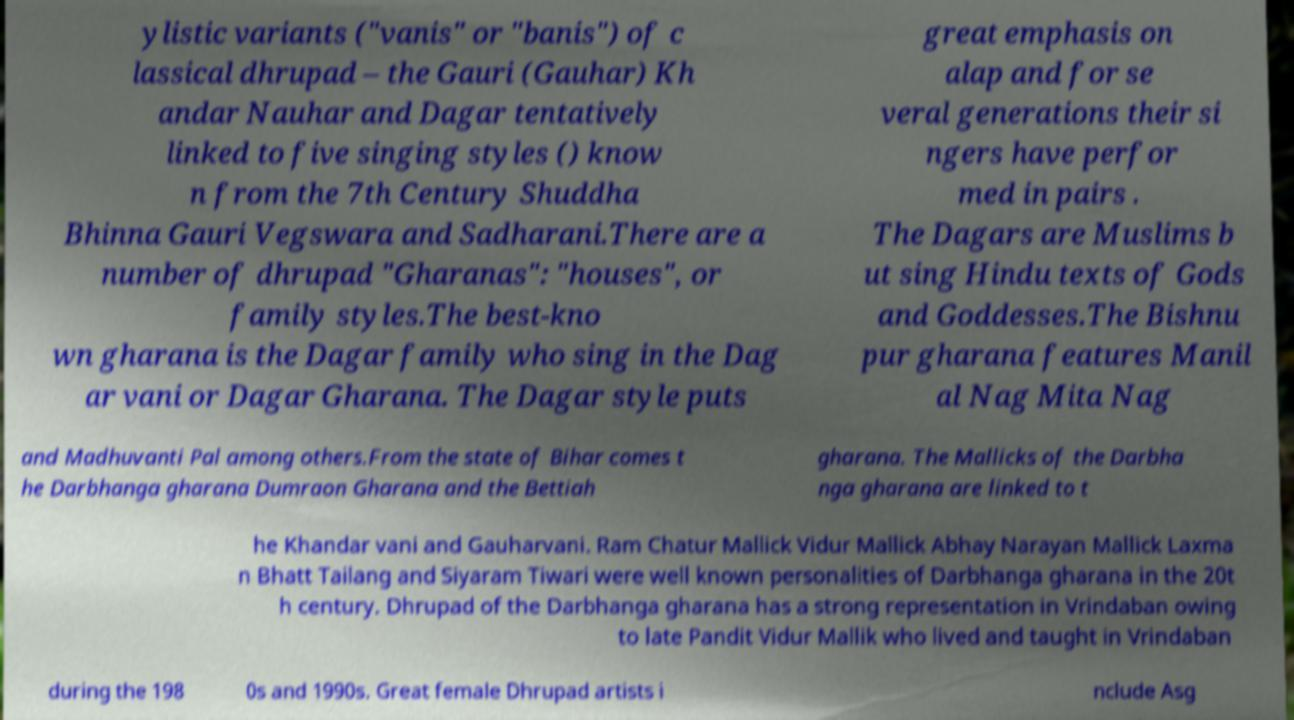Could you assist in decoding the text presented in this image and type it out clearly? ylistic variants ("vanis" or "banis") of c lassical dhrupad – the Gauri (Gauhar) Kh andar Nauhar and Dagar tentatively linked to five singing styles () know n from the 7th Century Shuddha Bhinna Gauri Vegswara and Sadharani.There are a number of dhrupad "Gharanas": "houses", or family styles.The best-kno wn gharana is the Dagar family who sing in the Dag ar vani or Dagar Gharana. The Dagar style puts great emphasis on alap and for se veral generations their si ngers have perfor med in pairs . The Dagars are Muslims b ut sing Hindu texts of Gods and Goddesses.The Bishnu pur gharana features Manil al Nag Mita Nag and Madhuvanti Pal among others.From the state of Bihar comes t he Darbhanga gharana Dumraon Gharana and the Bettiah gharana. The Mallicks of the Darbha nga gharana are linked to t he Khandar vani and Gauharvani. Ram Chatur Mallick Vidur Mallick Abhay Narayan Mallick Laxma n Bhatt Tailang and Siyaram Tiwari were well known personalities of Darbhanga gharana in the 20t h century. Dhrupad of the Darbhanga gharana has a strong representation in Vrindaban owing to late Pandit Vidur Mallik who lived and taught in Vrindaban during the 198 0s and 1990s. Great female Dhrupad artists i nclude Asg 